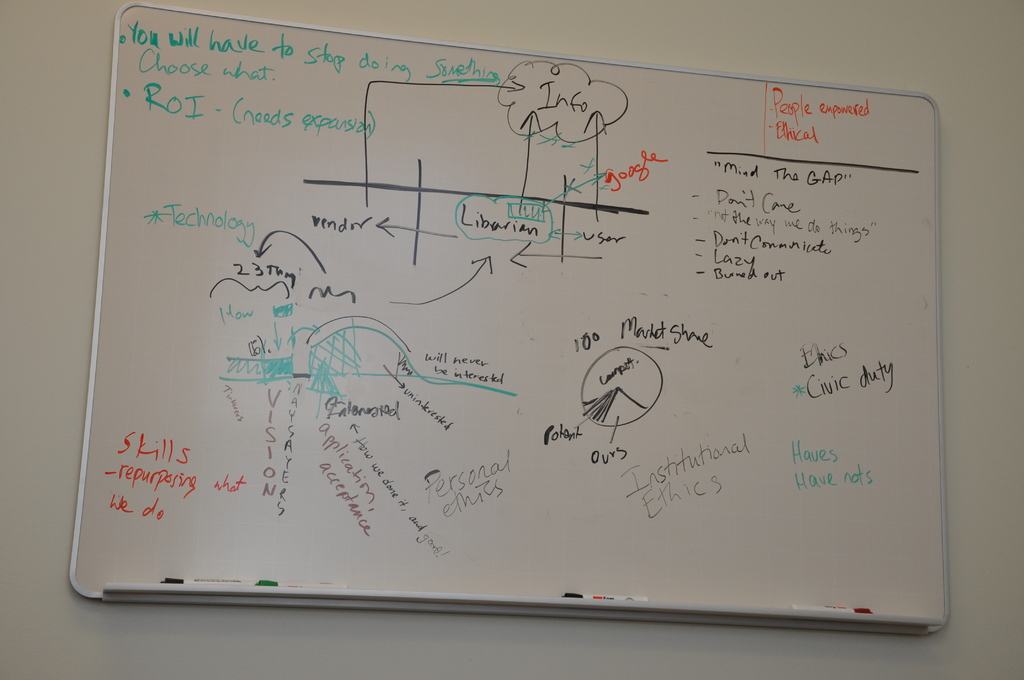What do you see happening in this image? The image shows a whiteboard being used during an intense brainstorming session. The board is covered with various terms, diagrams, and annotations, signaling a robust discussion focused on improving operational efficiency and addressing ethical concerns within an organization. Phrases like 'Choose what to stop doing' and 'ROI', which is highlighted as needing expansion, suggest a strategic review of activities and investments to enhance productivity and returns. The lively use of colors and multiple handwriting styles indicates the participation of various individuals, contributing to a collaborative environment. Keywords such as 'Technology', '100% Product Share', and 'Institutional Ethics' indicate that the focus is on technological advancements, market competition, and maintaining ethical standards. The drawing of the bridge, labeled with 'Librarian' and 'User', symbolizes the need for bridging communication gaps between different stakeholders or departments within the institution. 